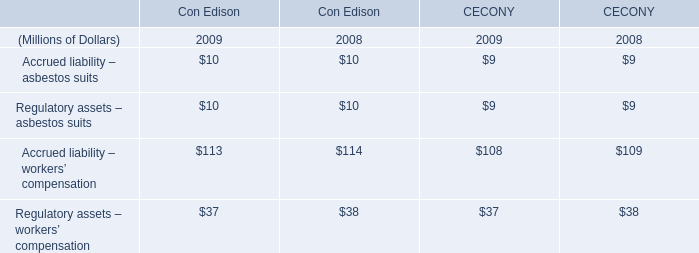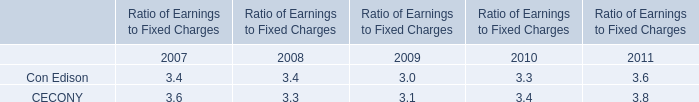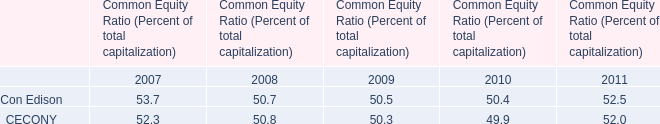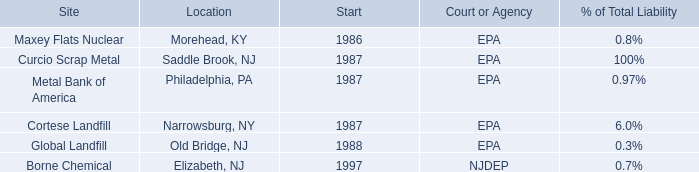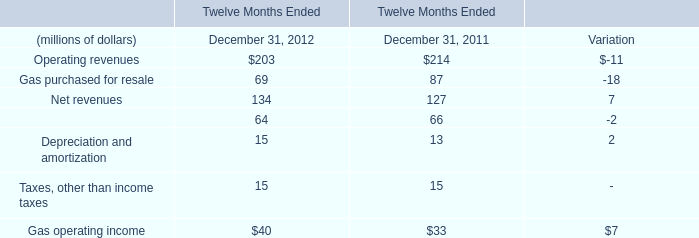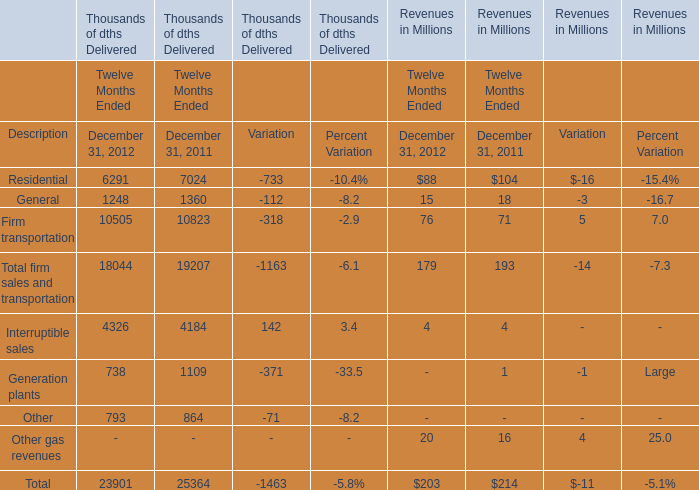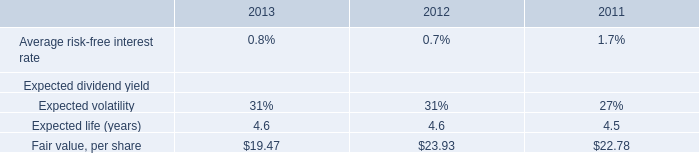What will Net revenues reach in 2013 if it continues to grow at its current rate? (in million) 
Computations: (134 * (1 + (7 / 127)))
Answer: 141.38583. 